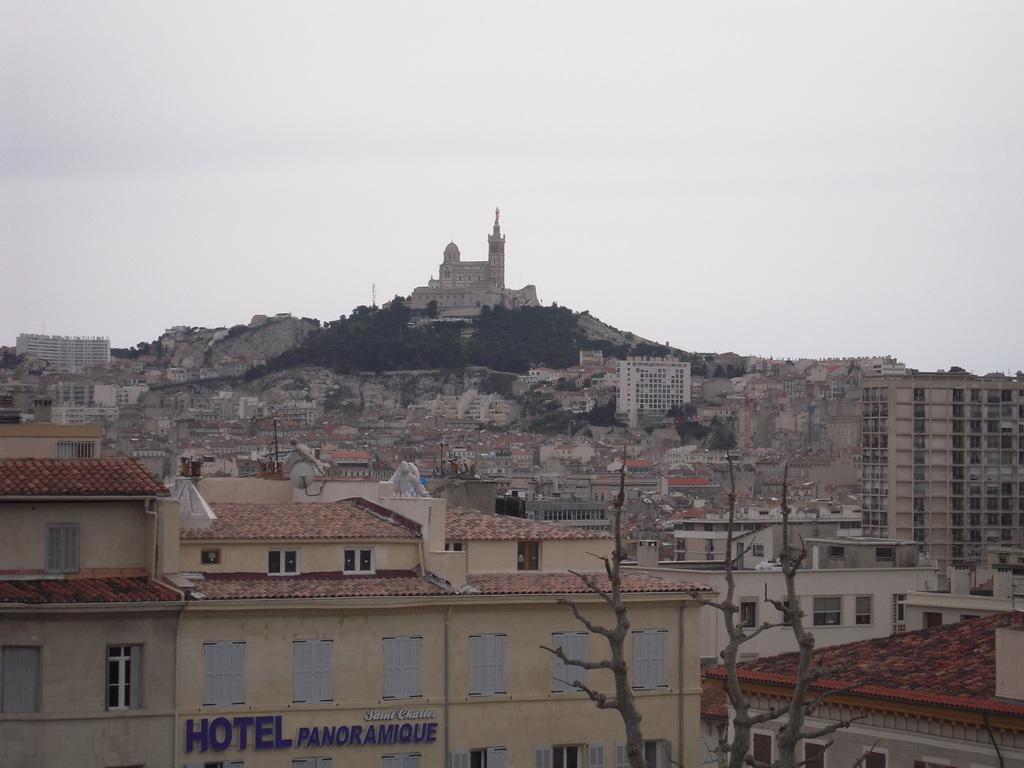What type of structures can be seen in the image? There are buildings in the image. Can you describe the location of one of the buildings? There is a building on a hill in the image. What other natural elements are present in the image? There are trees in the image. What can be seen in the background of the image? The sky is visible in the background of the image. How many snakes can be seen slithering through the buildings in the image? There are no snakes present in the image; it features buildings, trees, and a sky background. What type of wave can be seen crashing against the buildings in the image? There is no wave present in the image; it is a landscape featuring buildings, trees, and a sky background. 